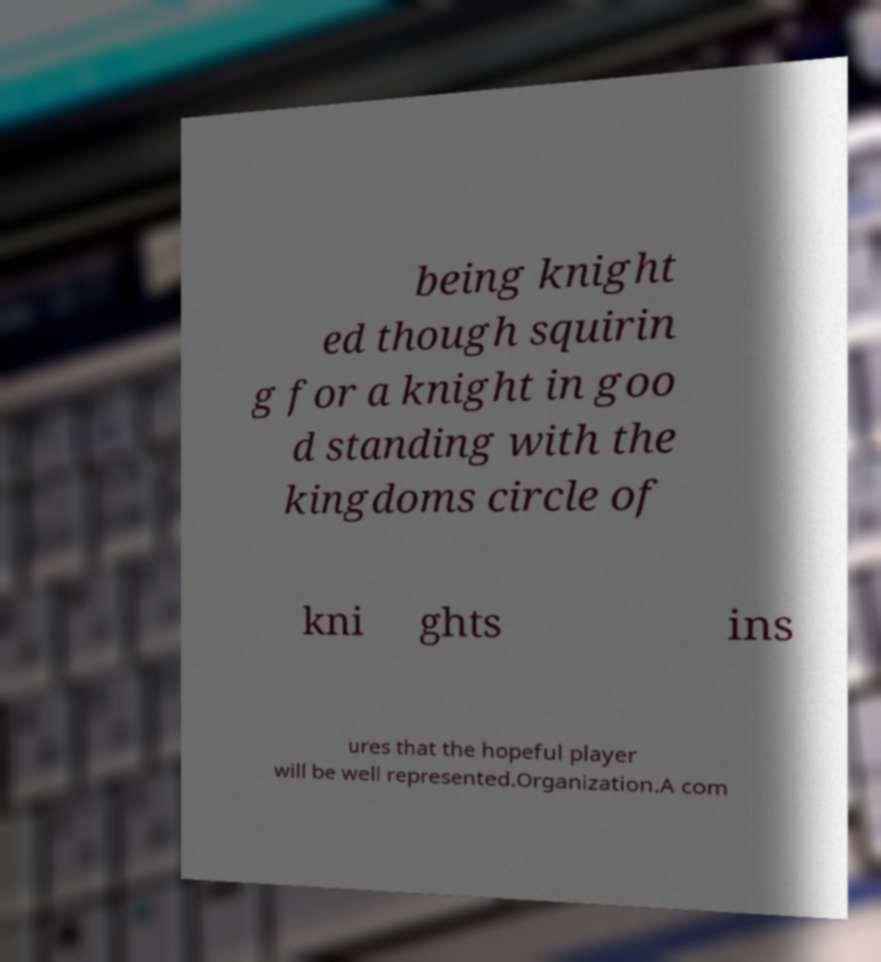I need the written content from this picture converted into text. Can you do that? being knight ed though squirin g for a knight in goo d standing with the kingdoms circle of kni ghts ins ures that the hopeful player will be well represented.Organization.A com 